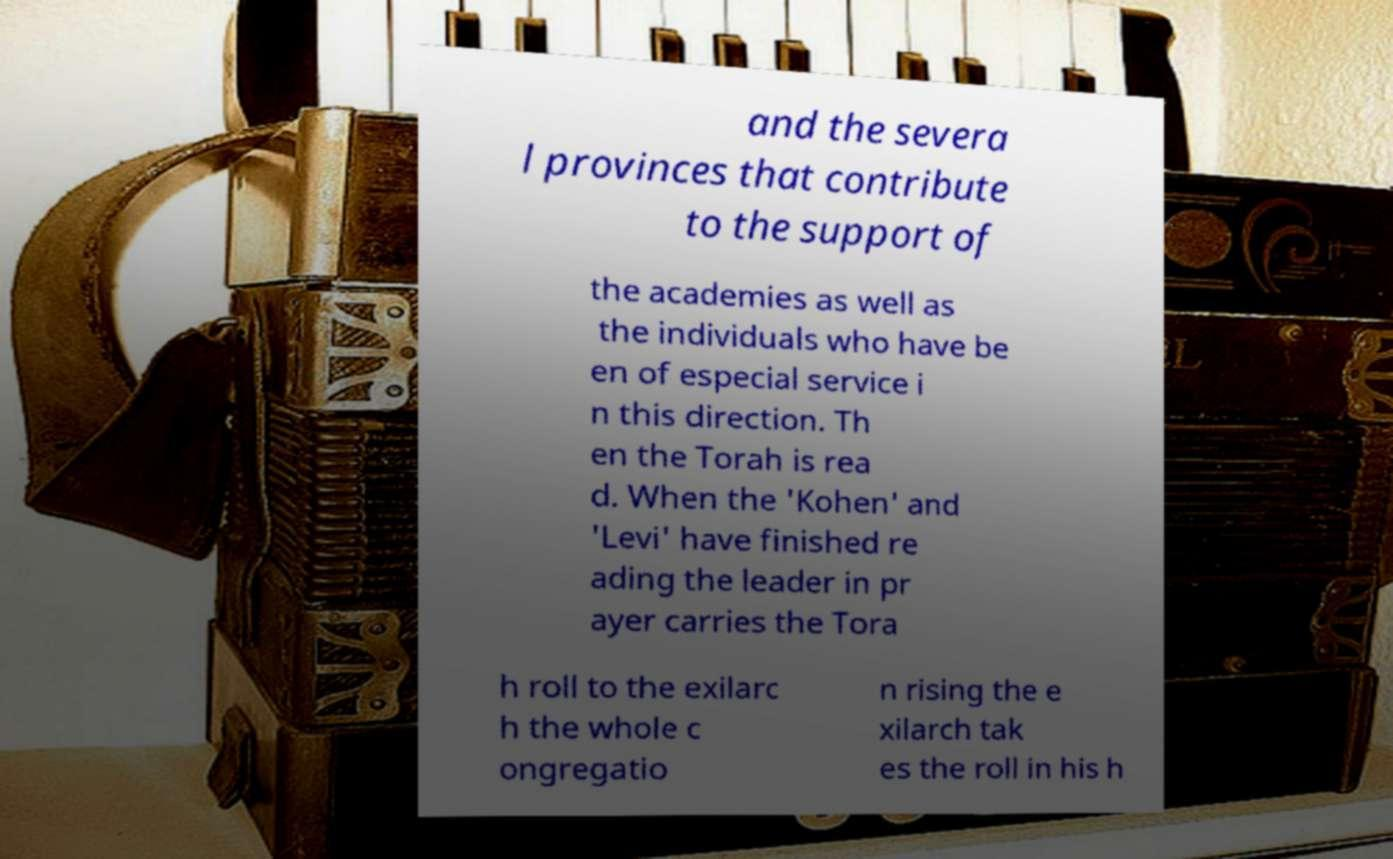Can you accurately transcribe the text from the provided image for me? and the severa l provinces that contribute to the support of the academies as well as the individuals who have be en of especial service i n this direction. Th en the Torah is rea d. When the 'Kohen' and 'Levi' have finished re ading the leader in pr ayer carries the Tora h roll to the exilarc h the whole c ongregatio n rising the e xilarch tak es the roll in his h 